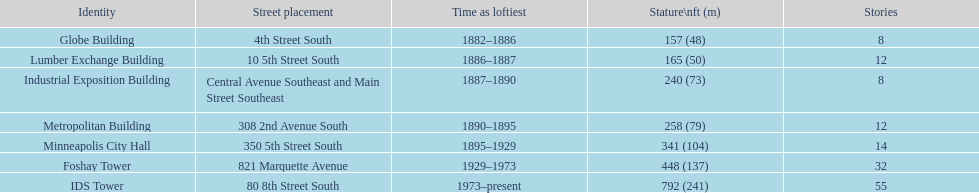How tall is it to the top of the ids tower in feet? 792. 